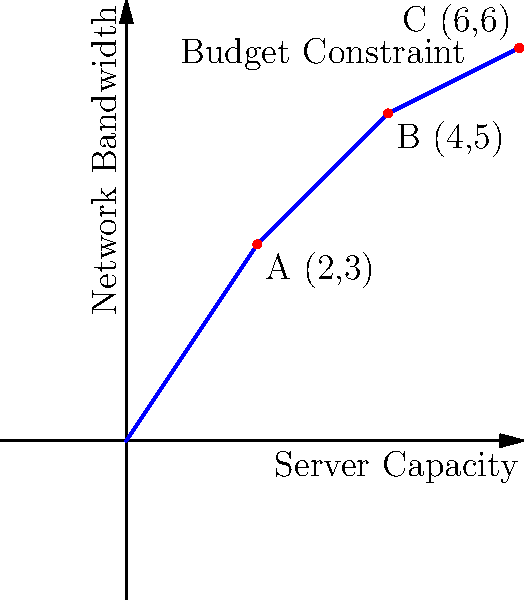As the technology department head, you are planning the expansion of your digital infrastructure. The graph shows the relationship between server capacity and network bandwidth, with points A, B, and C representing different expansion options. The blue line represents the budget constraint. Which point represents the most cost-effective expansion path that maximizes both server capacity and network bandwidth within the given budget? To determine the most cost-effective expansion path, we need to analyze the given points in relation to the budget constraint line:

1. Point A (2,3): This point is below the budget constraint line, indicating that it doesn't fully utilize the available budget.

2. Point B (4,5): This point lies exactly on the budget constraint line, maximizing the use of the available budget.

3. Point C (6,6): This point is above the budget constraint line, indicating that it exceeds the available budget.

The most cost-effective solution should:
a) Lie on the budget constraint line to fully utilize the available resources.
b) Provide the highest possible combination of server capacity and network bandwidth.

Point B (4,5) satisfies both these criteria:
- It lies on the budget constraint line, ensuring full budget utilization.
- It provides a higher combination of server capacity (4) and network bandwidth (5) compared to point A.
- While point C offers higher values, it's not feasible within the given budget.

Therefore, point B (4,5) represents the most cost-effective expansion path, maximizing both server capacity and network bandwidth within the given budget constraints.
Answer: Point B (4,5) 